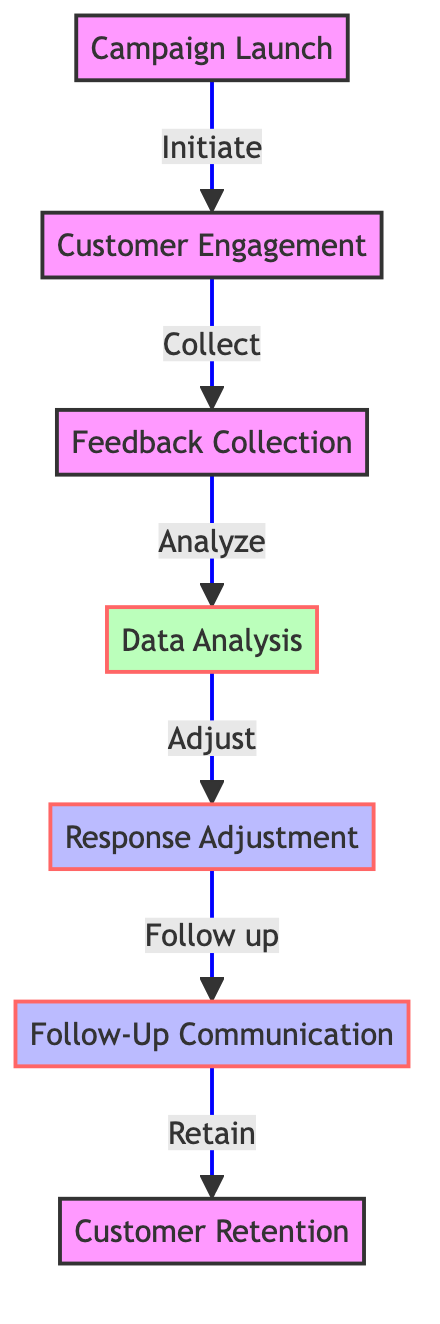What is the first stage of the promotional campaign? The diagram lists the first stage of the promotional campaign as "Campaign Launch." This is the initial node in the directed graph, indicating the starting point of the flow.
Answer: Campaign Launch How many stages are outlined in the diagram? Counting the nodes in the directed graph, there are seven distinct stages represented. Each stage corresponds to a specific step in the campaign flow.
Answer: 7 What follows after Customer Engagement? Looking at the connections in the diagram, "Feedback Collection" is the next stage that follows "Customer Engagement." The directed flow shows this direct relationship.
Answer: Feedback Collection Which stage involves analyzing customer responses? The stage that focuses on analyzing customer responses is "Data Analysis." This is clearly marked in the diagram and follows the "Feedback Collection" stage.
Answer: Data Analysis What is the relationship between Data Analysis and Response Adjustment? The relationship is a directional flow from "Data Analysis" to "Response Adjustment," indicating that adjustments are made based on the analyses conducted during the Data Analysis stage.
Answer: Adjust Why is Follow-Up Communication important? Follow-Up Communication plays a crucial role in retaining customers after feedback has been collected and responses have been adjusted. It is essential for maintaining customer relationships.
Answer: Retain What action does the campaign take after collecting feedback? After collecting feedback, the action taken is "Data Analysis," where customer interactions and insights are analyzed thoroughly. This is the next node in the flow.
Answer: Data Analysis How many connections are there in total within the diagram? There are six connections that depict the flow between stages in the diagram, showcasing how they sequentially relate to one another in the communication process.
Answer: 6 What do the filled colors of nodes represent in the diagram? The filled colors represent classifications of the stages, such as processes and analyses, which help to differentiate the type of actions or focus at each stage in the promotional campaign.
Answer: Classification 